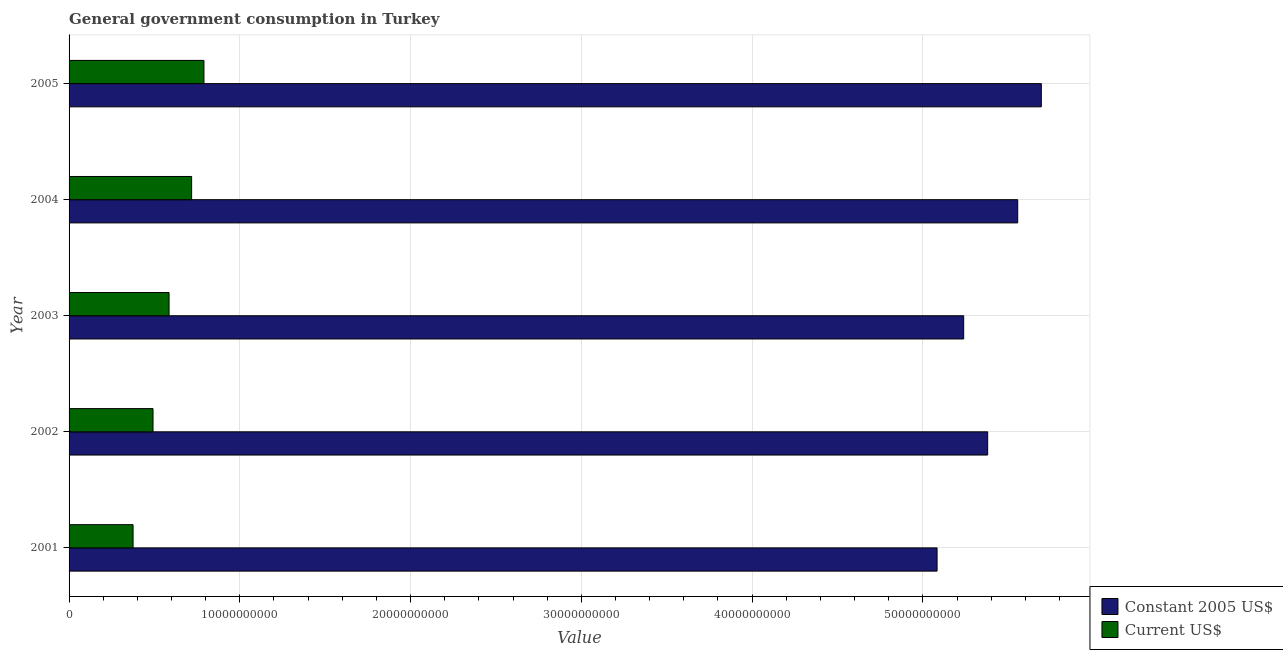How many different coloured bars are there?
Your answer should be compact. 2. How many groups of bars are there?
Your answer should be compact. 5. Are the number of bars per tick equal to the number of legend labels?
Offer a terse response. Yes. How many bars are there on the 3rd tick from the top?
Make the answer very short. 2. What is the value consumed in constant 2005 us$ in 2002?
Ensure brevity in your answer.  5.38e+1. Across all years, what is the maximum value consumed in constant 2005 us$?
Keep it short and to the point. 5.69e+1. Across all years, what is the minimum value consumed in constant 2005 us$?
Offer a very short reply. 5.08e+1. In which year was the value consumed in constant 2005 us$ maximum?
Provide a short and direct response. 2005. What is the total value consumed in current us$ in the graph?
Give a very brief answer. 2.96e+1. What is the difference between the value consumed in constant 2005 us$ in 2001 and that in 2003?
Provide a short and direct response. -1.56e+09. What is the difference between the value consumed in constant 2005 us$ in 2005 and the value consumed in current us$ in 2003?
Your answer should be very brief. 5.11e+1. What is the average value consumed in constant 2005 us$ per year?
Provide a short and direct response. 5.39e+1. In the year 2003, what is the difference between the value consumed in constant 2005 us$ and value consumed in current us$?
Provide a short and direct response. 4.65e+1. What is the ratio of the value consumed in constant 2005 us$ in 2001 to that in 2004?
Offer a terse response. 0.92. What is the difference between the highest and the second highest value consumed in current us$?
Your answer should be compact. 7.22e+08. What is the difference between the highest and the lowest value consumed in current us$?
Keep it short and to the point. 4.15e+09. Is the sum of the value consumed in constant 2005 us$ in 2004 and 2005 greater than the maximum value consumed in current us$ across all years?
Offer a terse response. Yes. What does the 2nd bar from the top in 2005 represents?
Provide a short and direct response. Constant 2005 US$. What does the 1st bar from the bottom in 2005 represents?
Offer a very short reply. Constant 2005 US$. How many bars are there?
Make the answer very short. 10. Are all the bars in the graph horizontal?
Offer a terse response. Yes. How many years are there in the graph?
Your answer should be compact. 5. What is the difference between two consecutive major ticks on the X-axis?
Offer a terse response. 1.00e+1. Are the values on the major ticks of X-axis written in scientific E-notation?
Offer a terse response. No. Does the graph contain any zero values?
Make the answer very short. No. Does the graph contain grids?
Provide a short and direct response. Yes. How are the legend labels stacked?
Your answer should be very brief. Vertical. What is the title of the graph?
Offer a terse response. General government consumption in Turkey. Does "Secondary school" appear as one of the legend labels in the graph?
Keep it short and to the point. No. What is the label or title of the X-axis?
Ensure brevity in your answer.  Value. What is the Value of Constant 2005 US$ in 2001?
Your response must be concise. 5.08e+1. What is the Value in Current US$ in 2001?
Your answer should be very brief. 3.75e+09. What is the Value of Constant 2005 US$ in 2002?
Give a very brief answer. 5.38e+1. What is the Value in Current US$ in 2002?
Your answer should be very brief. 4.92e+09. What is the Value of Constant 2005 US$ in 2003?
Give a very brief answer. 5.24e+1. What is the Value of Current US$ in 2003?
Ensure brevity in your answer.  5.86e+09. What is the Value in Constant 2005 US$ in 2004?
Offer a very short reply. 5.56e+1. What is the Value in Current US$ in 2004?
Your response must be concise. 7.18e+09. What is the Value in Constant 2005 US$ in 2005?
Make the answer very short. 5.69e+1. What is the Value of Current US$ in 2005?
Your response must be concise. 7.90e+09. Across all years, what is the maximum Value of Constant 2005 US$?
Your response must be concise. 5.69e+1. Across all years, what is the maximum Value in Current US$?
Make the answer very short. 7.90e+09. Across all years, what is the minimum Value in Constant 2005 US$?
Provide a short and direct response. 5.08e+1. Across all years, what is the minimum Value in Current US$?
Give a very brief answer. 3.75e+09. What is the total Value of Constant 2005 US$ in the graph?
Keep it short and to the point. 2.70e+11. What is the total Value of Current US$ in the graph?
Offer a very short reply. 2.96e+1. What is the difference between the Value in Constant 2005 US$ in 2001 and that in 2002?
Keep it short and to the point. -2.96e+09. What is the difference between the Value of Current US$ in 2001 and that in 2002?
Your response must be concise. -1.17e+09. What is the difference between the Value in Constant 2005 US$ in 2001 and that in 2003?
Provide a succinct answer. -1.56e+09. What is the difference between the Value in Current US$ in 2001 and that in 2003?
Offer a very short reply. -2.11e+09. What is the difference between the Value of Constant 2005 US$ in 2001 and that in 2004?
Ensure brevity in your answer.  -4.72e+09. What is the difference between the Value in Current US$ in 2001 and that in 2004?
Your response must be concise. -3.43e+09. What is the difference between the Value of Constant 2005 US$ in 2001 and that in 2005?
Provide a succinct answer. -6.10e+09. What is the difference between the Value of Current US$ in 2001 and that in 2005?
Your response must be concise. -4.15e+09. What is the difference between the Value of Constant 2005 US$ in 2002 and that in 2003?
Provide a short and direct response. 1.40e+09. What is the difference between the Value in Current US$ in 2002 and that in 2003?
Your answer should be very brief. -9.39e+08. What is the difference between the Value of Constant 2005 US$ in 2002 and that in 2004?
Your response must be concise. -1.76e+09. What is the difference between the Value in Current US$ in 2002 and that in 2004?
Give a very brief answer. -2.26e+09. What is the difference between the Value in Constant 2005 US$ in 2002 and that in 2005?
Ensure brevity in your answer.  -3.14e+09. What is the difference between the Value in Current US$ in 2002 and that in 2005?
Ensure brevity in your answer.  -2.98e+09. What is the difference between the Value of Constant 2005 US$ in 2003 and that in 2004?
Make the answer very short. -3.16e+09. What is the difference between the Value of Current US$ in 2003 and that in 2004?
Your response must be concise. -1.32e+09. What is the difference between the Value of Constant 2005 US$ in 2003 and that in 2005?
Keep it short and to the point. -4.55e+09. What is the difference between the Value of Current US$ in 2003 and that in 2005?
Give a very brief answer. -2.04e+09. What is the difference between the Value of Constant 2005 US$ in 2004 and that in 2005?
Offer a terse response. -1.38e+09. What is the difference between the Value of Current US$ in 2004 and that in 2005?
Your response must be concise. -7.22e+08. What is the difference between the Value of Constant 2005 US$ in 2001 and the Value of Current US$ in 2002?
Your response must be concise. 4.59e+1. What is the difference between the Value of Constant 2005 US$ in 2001 and the Value of Current US$ in 2003?
Offer a very short reply. 4.50e+1. What is the difference between the Value in Constant 2005 US$ in 2001 and the Value in Current US$ in 2004?
Make the answer very short. 4.37e+1. What is the difference between the Value of Constant 2005 US$ in 2001 and the Value of Current US$ in 2005?
Offer a very short reply. 4.29e+1. What is the difference between the Value of Constant 2005 US$ in 2002 and the Value of Current US$ in 2003?
Ensure brevity in your answer.  4.79e+1. What is the difference between the Value in Constant 2005 US$ in 2002 and the Value in Current US$ in 2004?
Provide a short and direct response. 4.66e+1. What is the difference between the Value of Constant 2005 US$ in 2002 and the Value of Current US$ in 2005?
Keep it short and to the point. 4.59e+1. What is the difference between the Value of Constant 2005 US$ in 2003 and the Value of Current US$ in 2004?
Give a very brief answer. 4.52e+1. What is the difference between the Value of Constant 2005 US$ in 2003 and the Value of Current US$ in 2005?
Ensure brevity in your answer.  4.45e+1. What is the difference between the Value in Constant 2005 US$ in 2004 and the Value in Current US$ in 2005?
Your response must be concise. 4.77e+1. What is the average Value in Constant 2005 US$ per year?
Offer a terse response. 5.39e+1. What is the average Value of Current US$ per year?
Your answer should be very brief. 5.92e+09. In the year 2001, what is the difference between the Value of Constant 2005 US$ and Value of Current US$?
Your answer should be very brief. 4.71e+1. In the year 2002, what is the difference between the Value of Constant 2005 US$ and Value of Current US$?
Give a very brief answer. 4.89e+1. In the year 2003, what is the difference between the Value of Constant 2005 US$ and Value of Current US$?
Provide a short and direct response. 4.65e+1. In the year 2004, what is the difference between the Value of Constant 2005 US$ and Value of Current US$?
Provide a succinct answer. 4.84e+1. In the year 2005, what is the difference between the Value of Constant 2005 US$ and Value of Current US$?
Offer a terse response. 4.90e+1. What is the ratio of the Value in Constant 2005 US$ in 2001 to that in 2002?
Provide a succinct answer. 0.94. What is the ratio of the Value of Current US$ in 2001 to that in 2002?
Offer a very short reply. 0.76. What is the ratio of the Value in Constant 2005 US$ in 2001 to that in 2003?
Provide a succinct answer. 0.97. What is the ratio of the Value in Current US$ in 2001 to that in 2003?
Your response must be concise. 0.64. What is the ratio of the Value of Constant 2005 US$ in 2001 to that in 2004?
Keep it short and to the point. 0.92. What is the ratio of the Value of Current US$ in 2001 to that in 2004?
Provide a succinct answer. 0.52. What is the ratio of the Value in Constant 2005 US$ in 2001 to that in 2005?
Ensure brevity in your answer.  0.89. What is the ratio of the Value of Current US$ in 2001 to that in 2005?
Ensure brevity in your answer.  0.47. What is the ratio of the Value in Constant 2005 US$ in 2002 to that in 2003?
Offer a terse response. 1.03. What is the ratio of the Value in Current US$ in 2002 to that in 2003?
Your answer should be very brief. 0.84. What is the ratio of the Value in Constant 2005 US$ in 2002 to that in 2004?
Your answer should be compact. 0.97. What is the ratio of the Value in Current US$ in 2002 to that in 2004?
Ensure brevity in your answer.  0.69. What is the ratio of the Value of Constant 2005 US$ in 2002 to that in 2005?
Provide a succinct answer. 0.94. What is the ratio of the Value in Current US$ in 2002 to that in 2005?
Your answer should be compact. 0.62. What is the ratio of the Value in Constant 2005 US$ in 2003 to that in 2004?
Provide a succinct answer. 0.94. What is the ratio of the Value in Current US$ in 2003 to that in 2004?
Your answer should be compact. 0.82. What is the ratio of the Value in Constant 2005 US$ in 2003 to that in 2005?
Keep it short and to the point. 0.92. What is the ratio of the Value of Current US$ in 2003 to that in 2005?
Give a very brief answer. 0.74. What is the ratio of the Value of Constant 2005 US$ in 2004 to that in 2005?
Offer a very short reply. 0.98. What is the ratio of the Value in Current US$ in 2004 to that in 2005?
Your response must be concise. 0.91. What is the difference between the highest and the second highest Value of Constant 2005 US$?
Make the answer very short. 1.38e+09. What is the difference between the highest and the second highest Value of Current US$?
Offer a very short reply. 7.22e+08. What is the difference between the highest and the lowest Value in Constant 2005 US$?
Offer a very short reply. 6.10e+09. What is the difference between the highest and the lowest Value of Current US$?
Your response must be concise. 4.15e+09. 